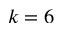<formula> <loc_0><loc_0><loc_500><loc_500>k = 6</formula> 